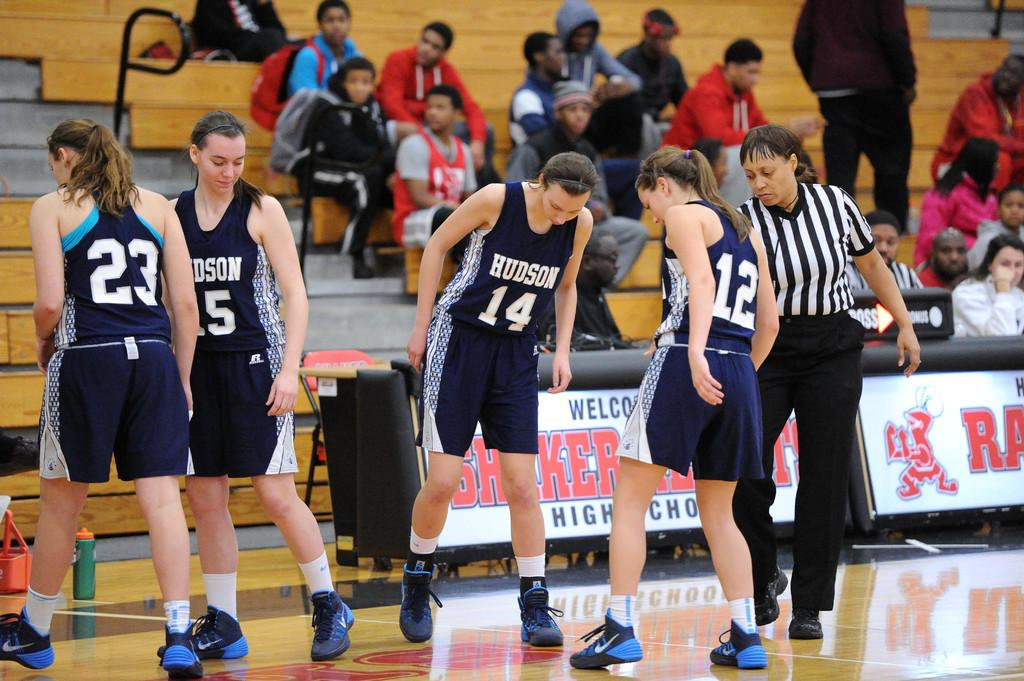What types of people are in the image? There are players and a referee in the image. What is the location of the players and referee? The players and referee are on the ground. What can be seen in the background of the image? There are stairs, persons, and an advertisement in the background of the image. Can you see any hens or dinosaurs in the image? No, there are no hens or dinosaurs present in the image. Is the image taken at a zoo? There is no information in the image to suggest that it was taken at a zoo. 